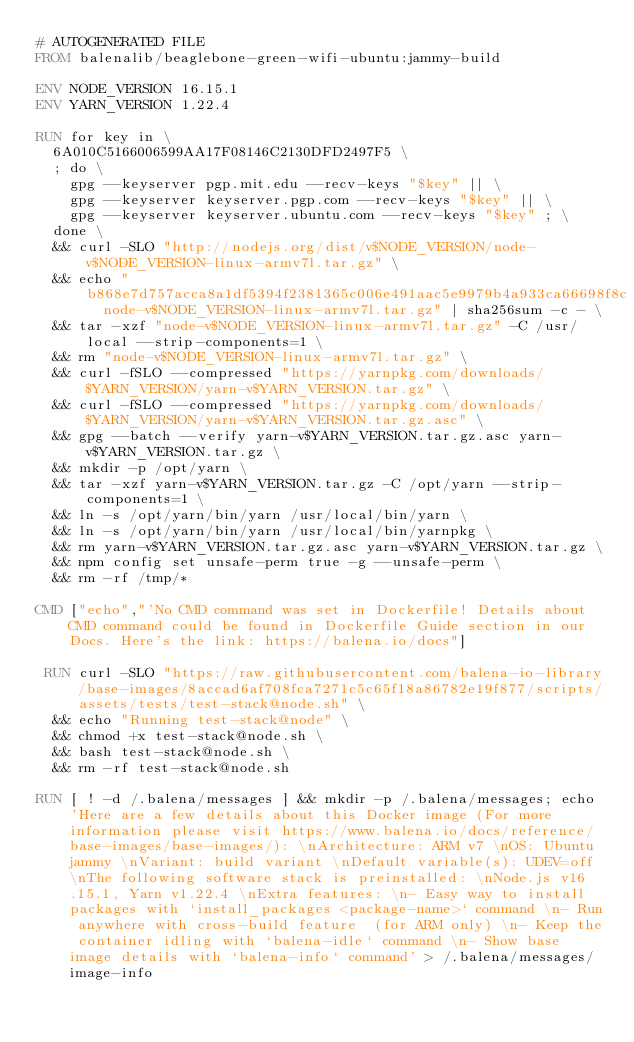Convert code to text. <code><loc_0><loc_0><loc_500><loc_500><_Dockerfile_># AUTOGENERATED FILE
FROM balenalib/beaglebone-green-wifi-ubuntu:jammy-build

ENV NODE_VERSION 16.15.1
ENV YARN_VERSION 1.22.4

RUN for key in \
	6A010C5166006599AA17F08146C2130DFD2497F5 \
	; do \
		gpg --keyserver pgp.mit.edu --recv-keys "$key" || \
		gpg --keyserver keyserver.pgp.com --recv-keys "$key" || \
		gpg --keyserver keyserver.ubuntu.com --recv-keys "$key" ; \
	done \
	&& curl -SLO "http://nodejs.org/dist/v$NODE_VERSION/node-v$NODE_VERSION-linux-armv7l.tar.gz" \
	&& echo "b868e7d757acca8a1df5394f2381365c006e491aac5e9979b4a933ca66698f8c  node-v$NODE_VERSION-linux-armv7l.tar.gz" | sha256sum -c - \
	&& tar -xzf "node-v$NODE_VERSION-linux-armv7l.tar.gz" -C /usr/local --strip-components=1 \
	&& rm "node-v$NODE_VERSION-linux-armv7l.tar.gz" \
	&& curl -fSLO --compressed "https://yarnpkg.com/downloads/$YARN_VERSION/yarn-v$YARN_VERSION.tar.gz" \
	&& curl -fSLO --compressed "https://yarnpkg.com/downloads/$YARN_VERSION/yarn-v$YARN_VERSION.tar.gz.asc" \
	&& gpg --batch --verify yarn-v$YARN_VERSION.tar.gz.asc yarn-v$YARN_VERSION.tar.gz \
	&& mkdir -p /opt/yarn \
	&& tar -xzf yarn-v$YARN_VERSION.tar.gz -C /opt/yarn --strip-components=1 \
	&& ln -s /opt/yarn/bin/yarn /usr/local/bin/yarn \
	&& ln -s /opt/yarn/bin/yarn /usr/local/bin/yarnpkg \
	&& rm yarn-v$YARN_VERSION.tar.gz.asc yarn-v$YARN_VERSION.tar.gz \
	&& npm config set unsafe-perm true -g --unsafe-perm \
	&& rm -rf /tmp/*

CMD ["echo","'No CMD command was set in Dockerfile! Details about CMD command could be found in Dockerfile Guide section in our Docs. Here's the link: https://balena.io/docs"]

 RUN curl -SLO "https://raw.githubusercontent.com/balena-io-library/base-images/8accad6af708fca7271c5c65f18a86782e19f877/scripts/assets/tests/test-stack@node.sh" \
  && echo "Running test-stack@node" \
  && chmod +x test-stack@node.sh \
  && bash test-stack@node.sh \
  && rm -rf test-stack@node.sh 

RUN [ ! -d /.balena/messages ] && mkdir -p /.balena/messages; echo 'Here are a few details about this Docker image (For more information please visit https://www.balena.io/docs/reference/base-images/base-images/): \nArchitecture: ARM v7 \nOS: Ubuntu jammy \nVariant: build variant \nDefault variable(s): UDEV=off \nThe following software stack is preinstalled: \nNode.js v16.15.1, Yarn v1.22.4 \nExtra features: \n- Easy way to install packages with `install_packages <package-name>` command \n- Run anywhere with cross-build feature  (for ARM only) \n- Keep the container idling with `balena-idle` command \n- Show base image details with `balena-info` command' > /.balena/messages/image-info</code> 